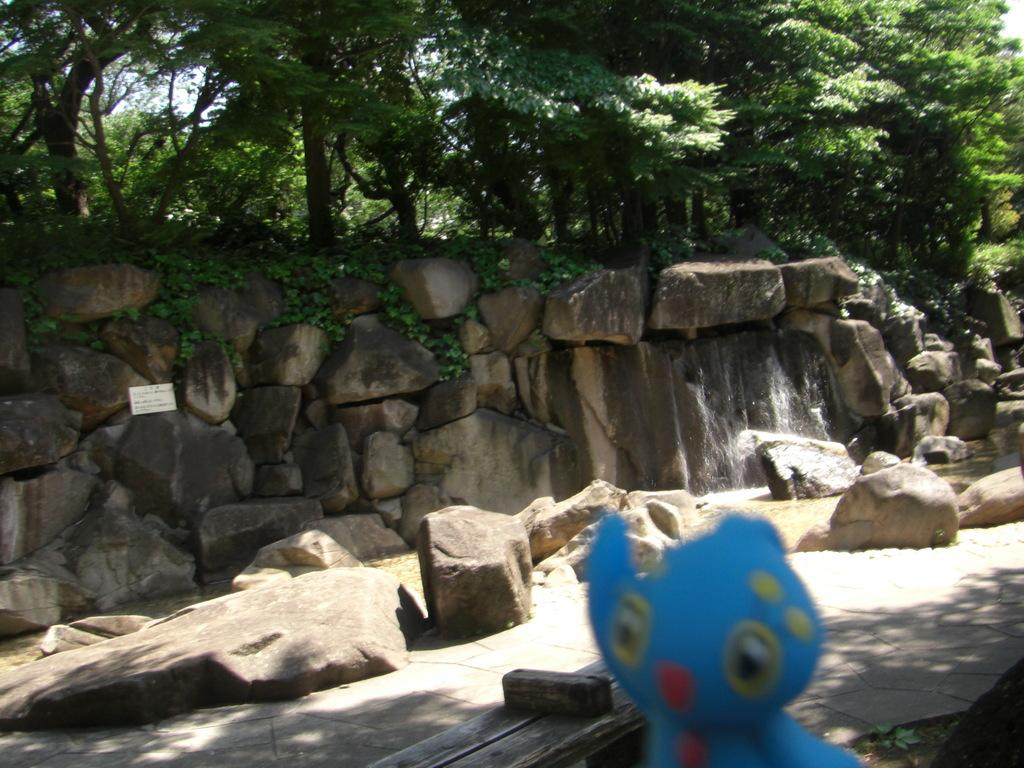What color is the toy in the image? The toy in the image is blue. What can be seen in the background of the image? There are rocks, water, and trees visible in the background of the image. What type of quilt is being used to cover the rocks in the image? There is no quilt present in the image, and the rocks are not covered. 